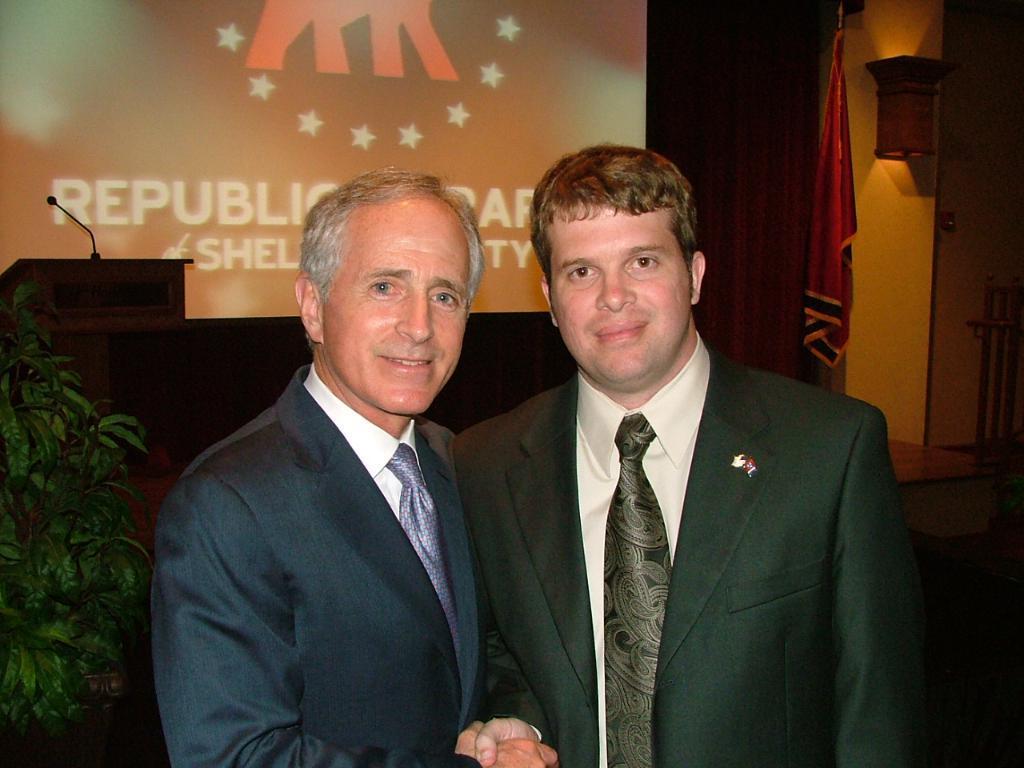Can you describe this image briefly? In the front of the image there are leaves and two people. Two people are giving each other a handshake. In the background of the image there is a light, wall, curtain, flag, screen, podium, mic, railing and objects. Something is written on the screen.   